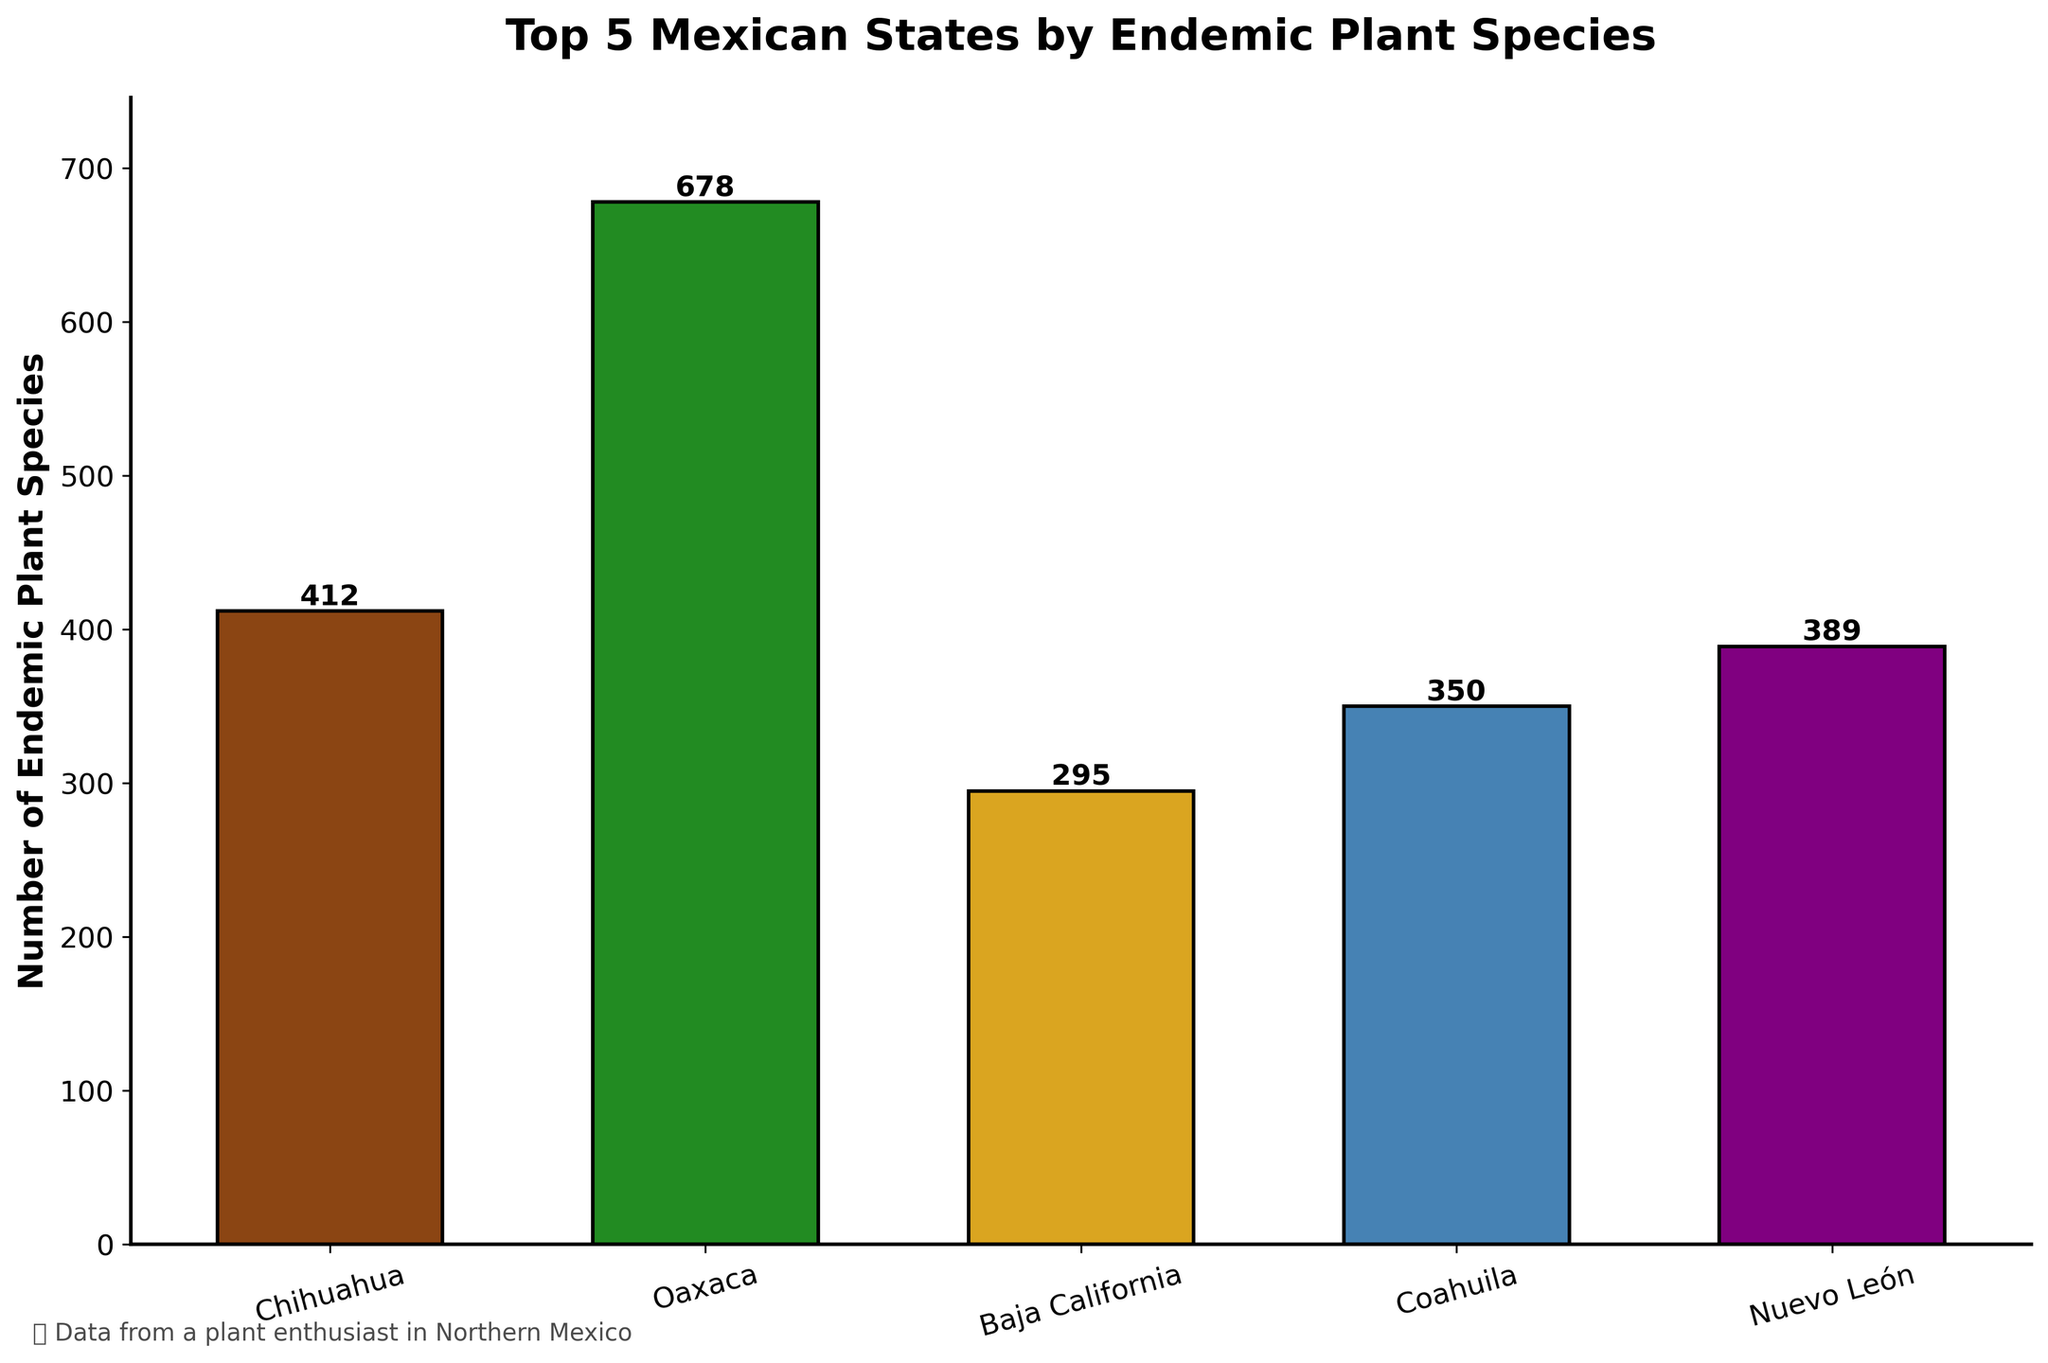Which Mexican state has the highest number of endemic plant species? The bar chart shows the number of endemic plant species for each state. Oaxaca's bar is the tallest, indicating it has the highest number.
Answer: Oaxaca How many more endemic plant species does Oaxaca have compared to Baja California? Oaxaca has 678 species and Baja California has 295. The difference is 678 - 295.
Answer: 383 What is the total number of endemic plant species in the top 5 states? Add the numbers for each state: 412 (Chihuahua) + 678 (Oaxaca) + 295 (Baja California) + 350 (Coahuila) + 389 (Nuevo León).
Answer: 2124 Which state ranks third in the number of endemic plant species? By comparing the heights of the bars, Coahuila has the third highest number of endemic plant species with 350.
Answer: Coahuila How many endemic plant species do the states with the least and most species have together? Oaxaca has the most with 678, and Baja California has the least with 295. The sum is 678 + 295.
Answer: 973 Is the number of endemic plant species in Chihuahua greater than in Coahuila? By comparing the bar heights, Chihuahua has 412 species while Coahuila has 350, so yes.
Answer: Yes What is the average number of endemic plant species across the five states? Add the values and divide by the number of states: (412 + 678 + 295 + 350 + 389) / 5.
Answer: 424.8 Which two states have the closest number of endemic plant species? By comparing the numbers, Chihuahua (412) and Nuevo León (389) are closest, with a difference of only 23.
Answer: Chihuahua and Nuevo León If you combine Baja California and Nuevo León's endemic plant species, would they surpass Chihuahua? Combine the numbers: 295 (Baja California) + 389 (Nuevo León) = 684. Compare this to 412 (Chihuahua). Yes, 684 is greater than 412.
Answer: Yes 